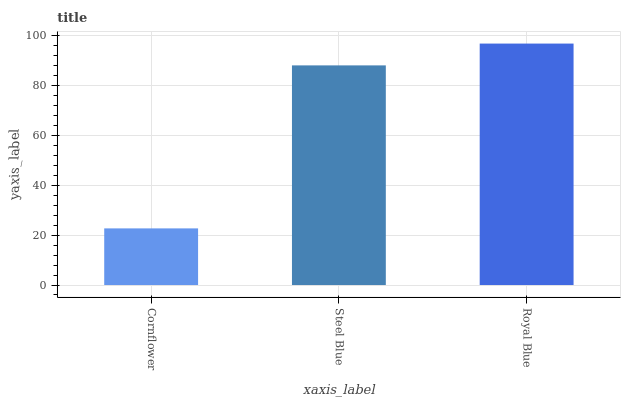Is Cornflower the minimum?
Answer yes or no. Yes. Is Royal Blue the maximum?
Answer yes or no. Yes. Is Steel Blue the minimum?
Answer yes or no. No. Is Steel Blue the maximum?
Answer yes or no. No. Is Steel Blue greater than Cornflower?
Answer yes or no. Yes. Is Cornflower less than Steel Blue?
Answer yes or no. Yes. Is Cornflower greater than Steel Blue?
Answer yes or no. No. Is Steel Blue less than Cornflower?
Answer yes or no. No. Is Steel Blue the high median?
Answer yes or no. Yes. Is Steel Blue the low median?
Answer yes or no. Yes. Is Cornflower the high median?
Answer yes or no. No. Is Royal Blue the low median?
Answer yes or no. No. 